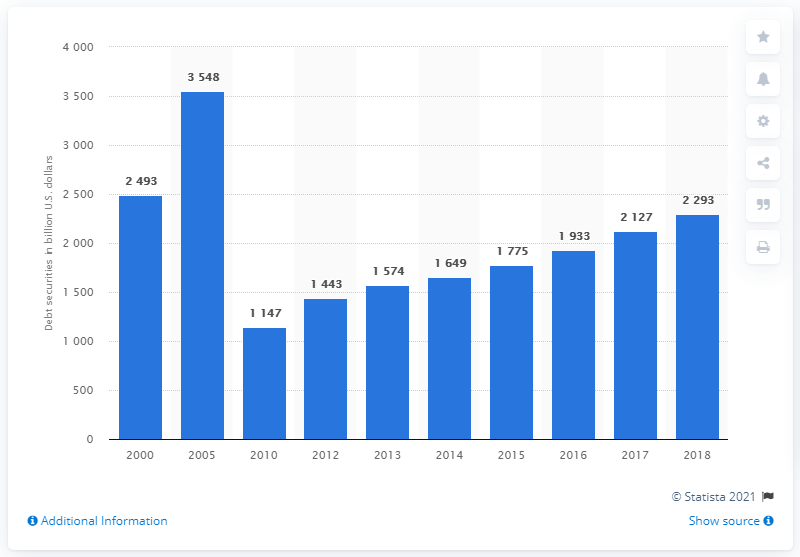Identify some key points in this picture. In 2018, the total debt securities for the agency- and GSE-backed mortgage pools sector in the United States was approximately 2293. 